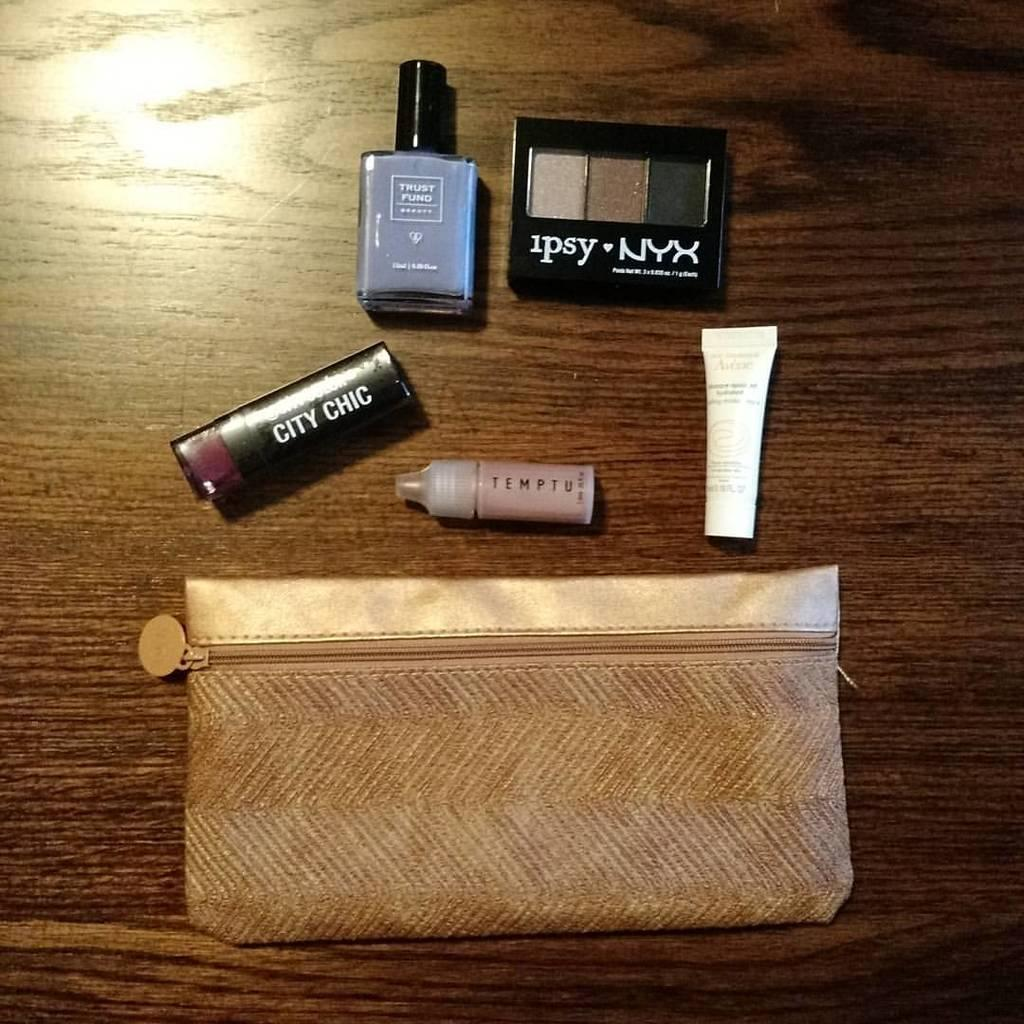Provide a one-sentence caption for the provided image. Makeup out of the bag on the table including City Chic & Temptu. 